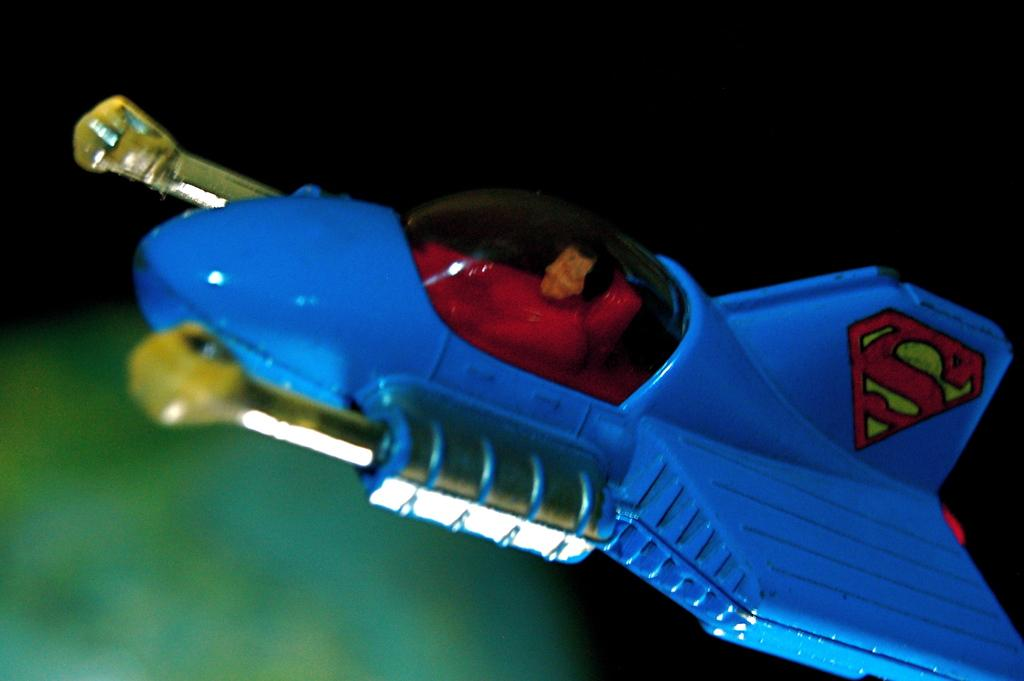<image>
Render a clear and concise summary of the photo. A small blue toy airplane has an S for Superman on the tail. 